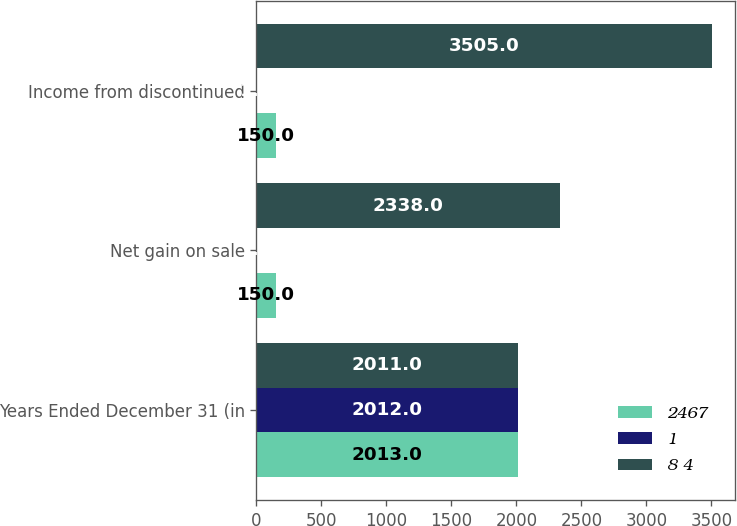Convert chart to OTSL. <chart><loc_0><loc_0><loc_500><loc_500><stacked_bar_chart><ecel><fcel>Years Ended December 31 (in<fcel>Net gain on sale<fcel>Income from discontinued<nl><fcel>2467<fcel>2013<fcel>150<fcel>150<nl><fcel>1<fcel>2012<fcel>1<fcel>1<nl><fcel>8 4<fcel>2011<fcel>2338<fcel>3505<nl></chart> 